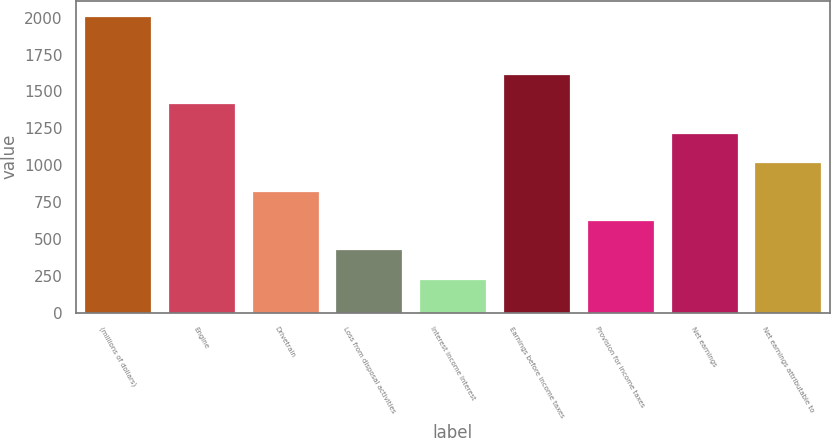<chart> <loc_0><loc_0><loc_500><loc_500><bar_chart><fcel>(millions of dollars)<fcel>Engine<fcel>Drivetrain<fcel>Loss from disposal activities<fcel>Interest income Interest<fcel>Earnings before income taxes<fcel>Provision for income taxes<fcel>Net earnings<fcel>Net earnings attributable to<nl><fcel>2014<fcel>1419.31<fcel>824.62<fcel>428.16<fcel>229.93<fcel>1617.54<fcel>626.39<fcel>1221.08<fcel>1022.85<nl></chart> 